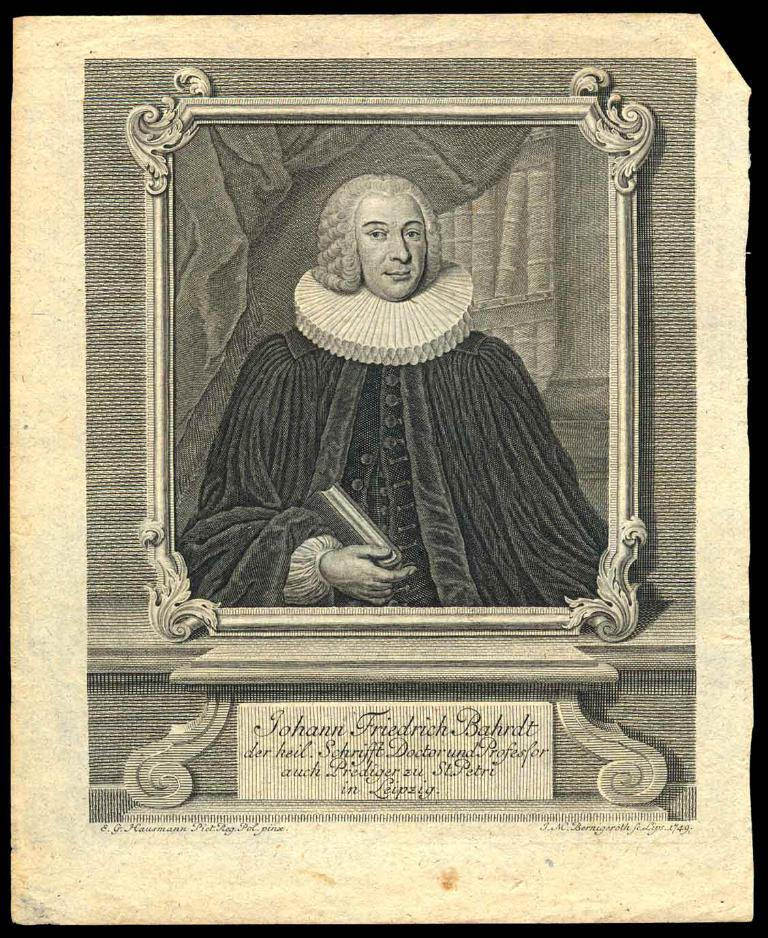What type of visual is the image? The image is a poster. What can be found on the poster? There is text and a frame on the poster. Who or what is depicted on the poster? There is a person depicted on the poster. What is the person holding in the image? The person is holding a book in his hand. What type of doll is the person holding in the image? There is no doll present in the image; the person is holding a book. What type of sail can be seen in the background of the image? There is no sail present in the image; the image is a poster with a person holding a book. 